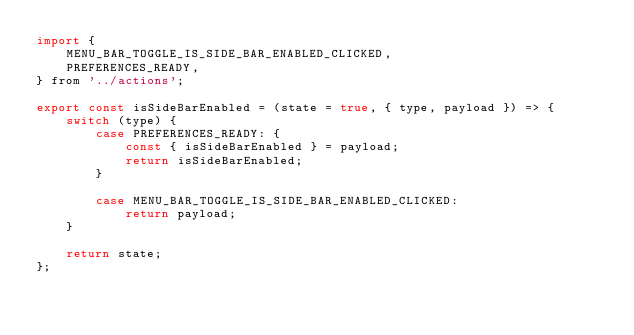Convert code to text. <code><loc_0><loc_0><loc_500><loc_500><_JavaScript_>import {
	MENU_BAR_TOGGLE_IS_SIDE_BAR_ENABLED_CLICKED,
	PREFERENCES_READY,
} from '../actions';

export const isSideBarEnabled = (state = true, { type, payload }) => {
	switch (type) {
		case PREFERENCES_READY: {
			const { isSideBarEnabled } = payload;
			return isSideBarEnabled;
		}

		case MENU_BAR_TOGGLE_IS_SIDE_BAR_ENABLED_CLICKED:
			return payload;
	}

	return state;
};
</code> 